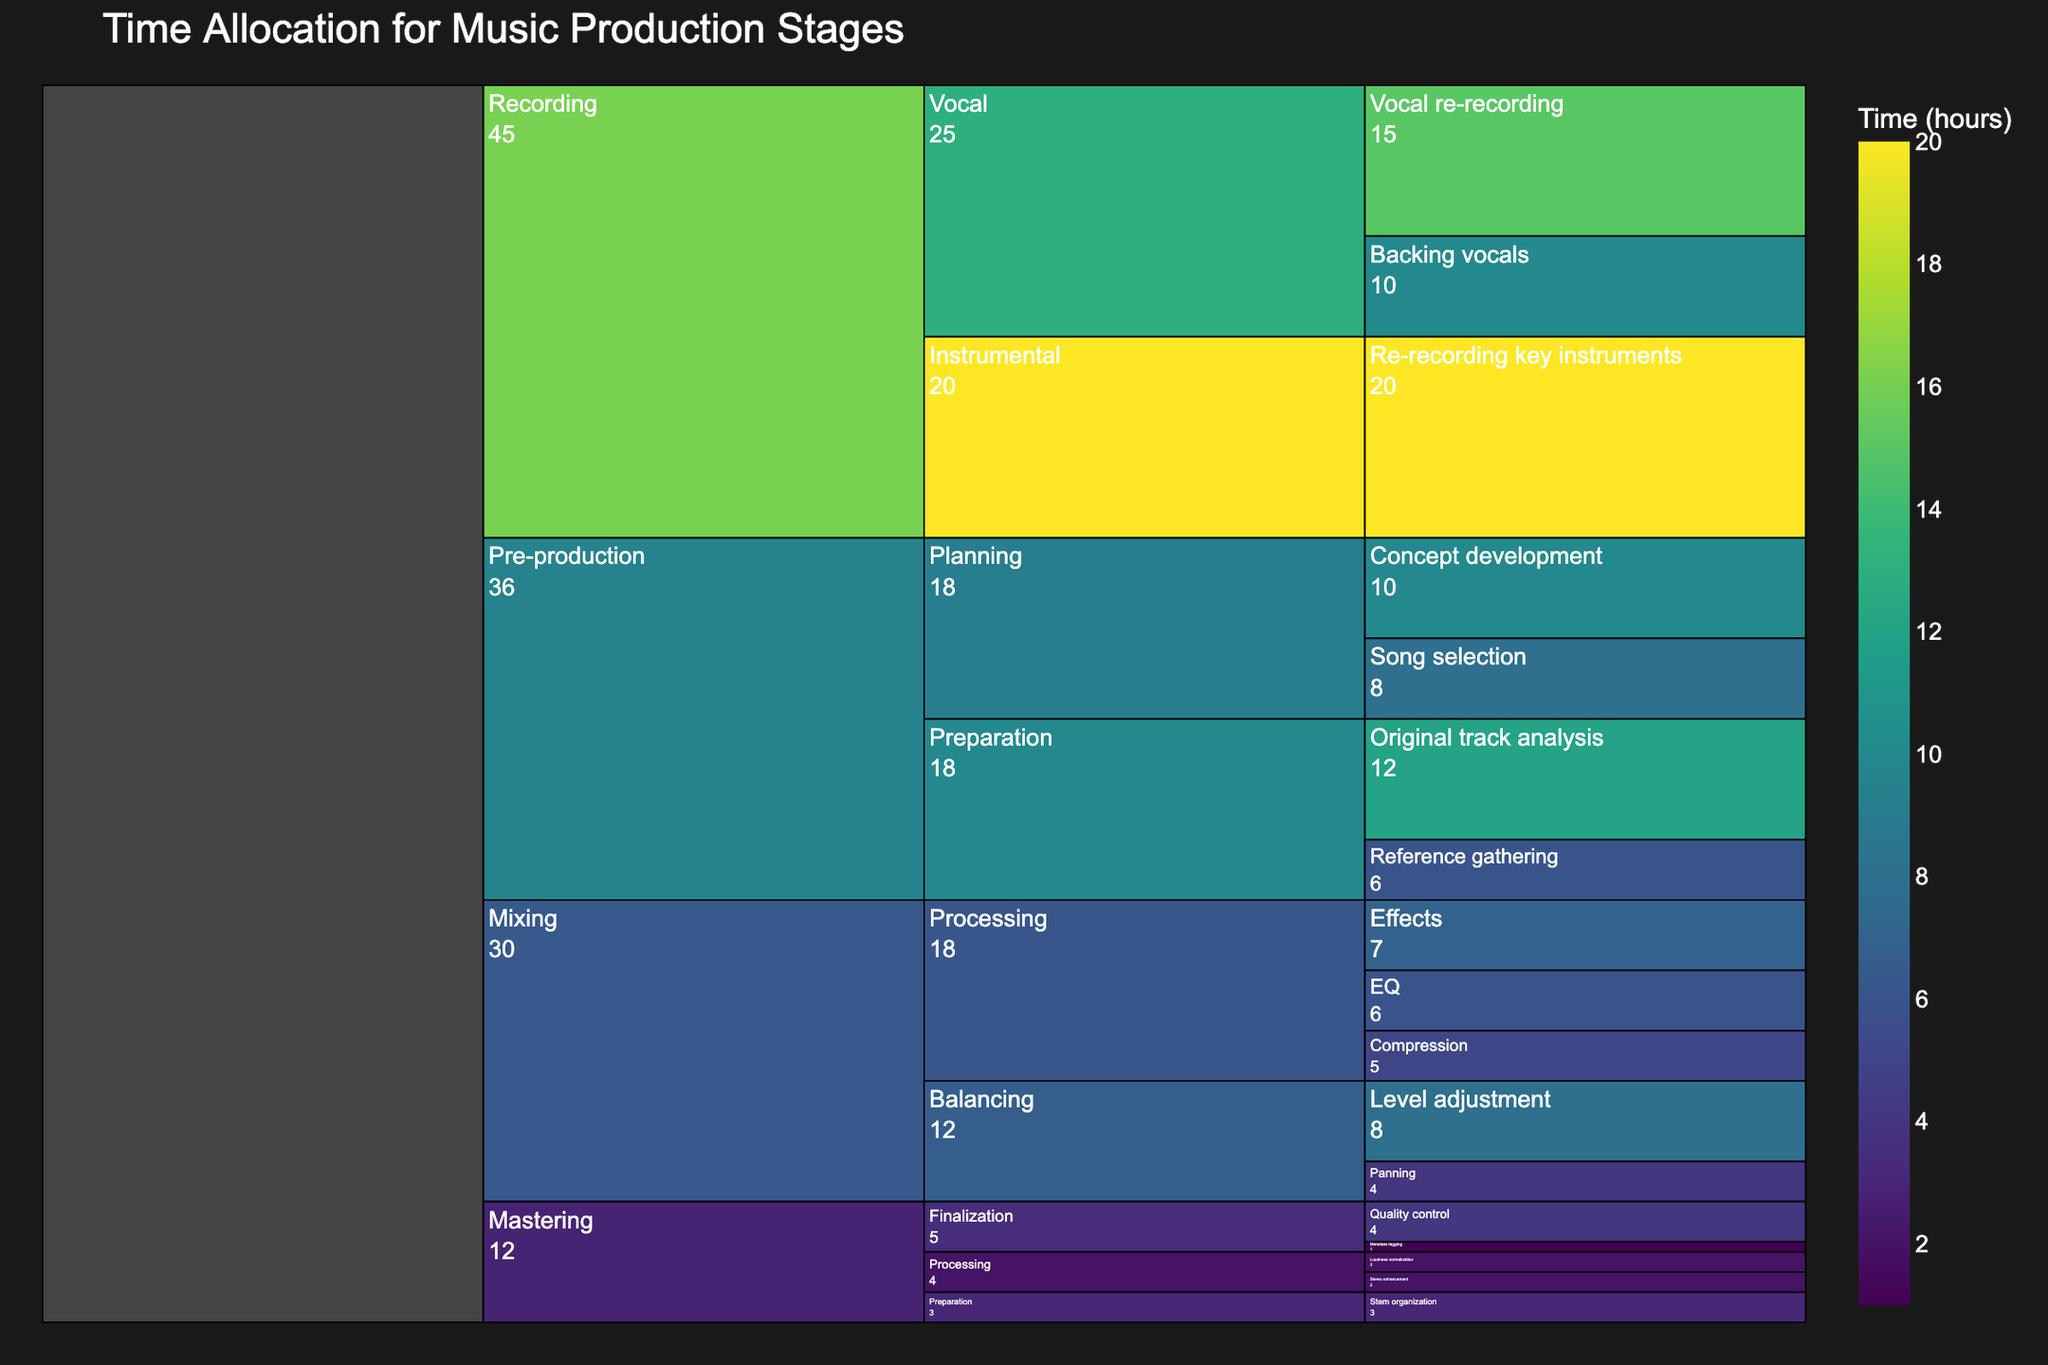Which stage of music production takes the most time overall? By looking at the largest segment in the icicle chart, we can determine which stage takes the most time. Recording has the largest segment, indicating it takes the most time.
Answer: Recording How many hours are allocated to Mixing's Processing substage? Adding up the hours allocated to EQ, Compression, and Effects tasks under Mixing's Processing substage: 6 (EQ) + 5 (Compression) + 7 (Effects) equals 18 hours.
Answer: 18 Which task in the Recording stage requires the most time? In the Recording stage, the tasks are Re-recording key instruments (20 hours), Vocal re-recording (15 hours), and Backing vocals (10 hours). The task with the most time is Re-recording key instruments with 20 hours.
Answer: Re-recording key instruments What's the shortest task duration in the Mastering stage? Within the Mastering stage, the tasks are Stem organization (3 hours), Loudness normalization (2 hours), Stereo enhancement (2 hours), Quality control (4 hours), and Metadata tagging (1 hour). The shortest task is Metadata tagging at 1 hour.
Answer: Metadata tagging Compare the time allocated for Planning and Preparation in the Pre-production stage. Which one takes more time? In the Pre-production stage, Planning has Concept development (10 hours) and Song selection (8 hours), totaling 18 hours. Preparation has Original track analysis (12 hours) and Reference gathering (6 hours), totaling 18 hours as well. Both sub-stages have the same time allocation.
Answer: They are equal How much time is spent on the entire Mastering stage? Adding the hours for all tasks in the Mastering stage: 3 (Stem organization) + 2 (Loudness normalization) + 2 (Stereo enhancement) + 4 (Quality control) + 1 (Metadata tagging) equals 12 hours.
Answer: 12 Which substage in the Mixing stage has the highest time allocation? Within the Mixing stage, Balancing substage includes Level adjustment (8 hours) and Panning (4 hours), totaling 12 hours. Processing substage includes EQ (6 hours), Compression (5 hours), and Effects (7 hours), totaling 18 hours. Processing has the highest time allocation.
Answer: Processing What's the average time spent on tasks in the Vocal substage of the Recording stage? The Vocal substage includes Vocal re-recording (15 hours) and Backing vocals (10 hours). The average is (15 + 10) / 2, which equals 12.5 hours.
Answer: 12.5 How does the time spent on EQ in Mixing compare to Vocal re-recording in Recording? EQ in Mixing takes 6 hours, while Vocal re-recording in Recording takes 15 hours. Vocal re-recording takes more time.
Answer: Vocal re-recording takes more time 